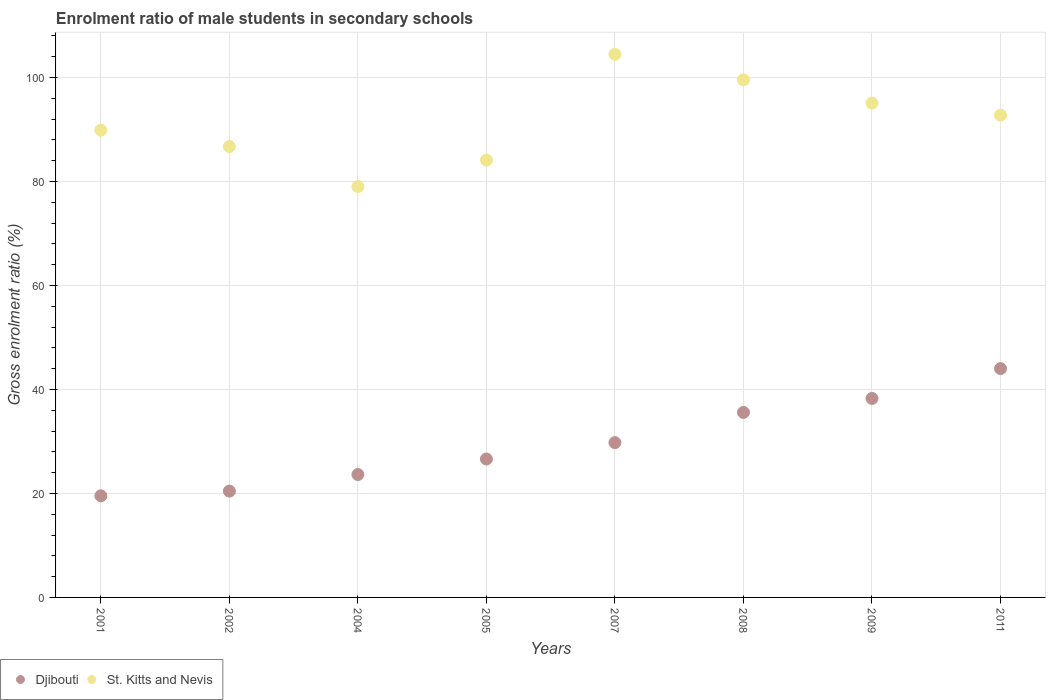How many different coloured dotlines are there?
Give a very brief answer. 2. What is the enrolment ratio of male students in secondary schools in St. Kitts and Nevis in 2007?
Make the answer very short. 104.44. Across all years, what is the maximum enrolment ratio of male students in secondary schools in Djibouti?
Offer a terse response. 44. Across all years, what is the minimum enrolment ratio of male students in secondary schools in St. Kitts and Nevis?
Your answer should be compact. 79.01. In which year was the enrolment ratio of male students in secondary schools in Djibouti maximum?
Give a very brief answer. 2011. In which year was the enrolment ratio of male students in secondary schools in St. Kitts and Nevis minimum?
Provide a succinct answer. 2004. What is the total enrolment ratio of male students in secondary schools in Djibouti in the graph?
Provide a short and direct response. 237.86. What is the difference between the enrolment ratio of male students in secondary schools in St. Kitts and Nevis in 2007 and that in 2008?
Ensure brevity in your answer.  4.9. What is the difference between the enrolment ratio of male students in secondary schools in Djibouti in 2004 and the enrolment ratio of male students in secondary schools in St. Kitts and Nevis in 2002?
Make the answer very short. -63.08. What is the average enrolment ratio of male students in secondary schools in St. Kitts and Nevis per year?
Give a very brief answer. 91.43. In the year 2007, what is the difference between the enrolment ratio of male students in secondary schools in Djibouti and enrolment ratio of male students in secondary schools in St. Kitts and Nevis?
Your response must be concise. -74.68. What is the ratio of the enrolment ratio of male students in secondary schools in St. Kitts and Nevis in 2001 to that in 2004?
Offer a very short reply. 1.14. Is the difference between the enrolment ratio of male students in secondary schools in Djibouti in 2002 and 2009 greater than the difference between the enrolment ratio of male students in secondary schools in St. Kitts and Nevis in 2002 and 2009?
Your response must be concise. No. What is the difference between the highest and the second highest enrolment ratio of male students in secondary schools in Djibouti?
Ensure brevity in your answer.  5.74. What is the difference between the highest and the lowest enrolment ratio of male students in secondary schools in Djibouti?
Give a very brief answer. 24.46. In how many years, is the enrolment ratio of male students in secondary schools in St. Kitts and Nevis greater than the average enrolment ratio of male students in secondary schools in St. Kitts and Nevis taken over all years?
Give a very brief answer. 4. Does the enrolment ratio of male students in secondary schools in St. Kitts and Nevis monotonically increase over the years?
Make the answer very short. No. Does the graph contain any zero values?
Provide a succinct answer. No. How many legend labels are there?
Ensure brevity in your answer.  2. What is the title of the graph?
Keep it short and to the point. Enrolment ratio of male students in secondary schools. Does "Turkmenistan" appear as one of the legend labels in the graph?
Give a very brief answer. No. What is the label or title of the X-axis?
Offer a very short reply. Years. What is the Gross enrolment ratio (%) of Djibouti in 2001?
Provide a short and direct response. 19.54. What is the Gross enrolment ratio (%) of St. Kitts and Nevis in 2001?
Provide a short and direct response. 89.86. What is the Gross enrolment ratio (%) in Djibouti in 2002?
Your answer should be compact. 20.45. What is the Gross enrolment ratio (%) of St. Kitts and Nevis in 2002?
Your answer should be very brief. 86.71. What is the Gross enrolment ratio (%) in Djibouti in 2004?
Your answer should be compact. 23.63. What is the Gross enrolment ratio (%) in St. Kitts and Nevis in 2004?
Keep it short and to the point. 79.01. What is the Gross enrolment ratio (%) in Djibouti in 2005?
Make the answer very short. 26.62. What is the Gross enrolment ratio (%) of St. Kitts and Nevis in 2005?
Make the answer very short. 84.11. What is the Gross enrolment ratio (%) of Djibouti in 2007?
Your response must be concise. 29.77. What is the Gross enrolment ratio (%) of St. Kitts and Nevis in 2007?
Your answer should be compact. 104.44. What is the Gross enrolment ratio (%) of Djibouti in 2008?
Your response must be concise. 35.58. What is the Gross enrolment ratio (%) of St. Kitts and Nevis in 2008?
Offer a very short reply. 99.54. What is the Gross enrolment ratio (%) of Djibouti in 2009?
Your answer should be compact. 38.27. What is the Gross enrolment ratio (%) in St. Kitts and Nevis in 2009?
Make the answer very short. 95.06. What is the Gross enrolment ratio (%) of Djibouti in 2011?
Give a very brief answer. 44. What is the Gross enrolment ratio (%) of St. Kitts and Nevis in 2011?
Your response must be concise. 92.74. Across all years, what is the maximum Gross enrolment ratio (%) in Djibouti?
Your answer should be very brief. 44. Across all years, what is the maximum Gross enrolment ratio (%) of St. Kitts and Nevis?
Offer a terse response. 104.44. Across all years, what is the minimum Gross enrolment ratio (%) of Djibouti?
Offer a terse response. 19.54. Across all years, what is the minimum Gross enrolment ratio (%) in St. Kitts and Nevis?
Make the answer very short. 79.01. What is the total Gross enrolment ratio (%) of Djibouti in the graph?
Your answer should be very brief. 237.86. What is the total Gross enrolment ratio (%) of St. Kitts and Nevis in the graph?
Keep it short and to the point. 731.47. What is the difference between the Gross enrolment ratio (%) of Djibouti in 2001 and that in 2002?
Your answer should be compact. -0.9. What is the difference between the Gross enrolment ratio (%) of St. Kitts and Nevis in 2001 and that in 2002?
Provide a succinct answer. 3.15. What is the difference between the Gross enrolment ratio (%) of Djibouti in 2001 and that in 2004?
Give a very brief answer. -4.09. What is the difference between the Gross enrolment ratio (%) of St. Kitts and Nevis in 2001 and that in 2004?
Ensure brevity in your answer.  10.85. What is the difference between the Gross enrolment ratio (%) in Djibouti in 2001 and that in 2005?
Keep it short and to the point. -7.07. What is the difference between the Gross enrolment ratio (%) in St. Kitts and Nevis in 2001 and that in 2005?
Ensure brevity in your answer.  5.75. What is the difference between the Gross enrolment ratio (%) in Djibouti in 2001 and that in 2007?
Offer a terse response. -10.22. What is the difference between the Gross enrolment ratio (%) in St. Kitts and Nevis in 2001 and that in 2007?
Offer a terse response. -14.58. What is the difference between the Gross enrolment ratio (%) in Djibouti in 2001 and that in 2008?
Keep it short and to the point. -16.03. What is the difference between the Gross enrolment ratio (%) of St. Kitts and Nevis in 2001 and that in 2008?
Keep it short and to the point. -9.68. What is the difference between the Gross enrolment ratio (%) of Djibouti in 2001 and that in 2009?
Your response must be concise. -18.72. What is the difference between the Gross enrolment ratio (%) in St. Kitts and Nevis in 2001 and that in 2009?
Offer a very short reply. -5.2. What is the difference between the Gross enrolment ratio (%) in Djibouti in 2001 and that in 2011?
Your answer should be very brief. -24.46. What is the difference between the Gross enrolment ratio (%) in St. Kitts and Nevis in 2001 and that in 2011?
Provide a short and direct response. -2.88. What is the difference between the Gross enrolment ratio (%) of Djibouti in 2002 and that in 2004?
Provide a succinct answer. -3.18. What is the difference between the Gross enrolment ratio (%) of St. Kitts and Nevis in 2002 and that in 2004?
Give a very brief answer. 7.69. What is the difference between the Gross enrolment ratio (%) in Djibouti in 2002 and that in 2005?
Keep it short and to the point. -6.17. What is the difference between the Gross enrolment ratio (%) in St. Kitts and Nevis in 2002 and that in 2005?
Ensure brevity in your answer.  2.6. What is the difference between the Gross enrolment ratio (%) of Djibouti in 2002 and that in 2007?
Your answer should be very brief. -9.32. What is the difference between the Gross enrolment ratio (%) of St. Kitts and Nevis in 2002 and that in 2007?
Keep it short and to the point. -17.74. What is the difference between the Gross enrolment ratio (%) of Djibouti in 2002 and that in 2008?
Give a very brief answer. -15.13. What is the difference between the Gross enrolment ratio (%) in St. Kitts and Nevis in 2002 and that in 2008?
Your answer should be compact. -12.83. What is the difference between the Gross enrolment ratio (%) in Djibouti in 2002 and that in 2009?
Give a very brief answer. -17.82. What is the difference between the Gross enrolment ratio (%) of St. Kitts and Nevis in 2002 and that in 2009?
Offer a terse response. -8.35. What is the difference between the Gross enrolment ratio (%) in Djibouti in 2002 and that in 2011?
Ensure brevity in your answer.  -23.56. What is the difference between the Gross enrolment ratio (%) in St. Kitts and Nevis in 2002 and that in 2011?
Give a very brief answer. -6.03. What is the difference between the Gross enrolment ratio (%) in Djibouti in 2004 and that in 2005?
Your answer should be very brief. -2.99. What is the difference between the Gross enrolment ratio (%) of St. Kitts and Nevis in 2004 and that in 2005?
Offer a terse response. -5.09. What is the difference between the Gross enrolment ratio (%) of Djibouti in 2004 and that in 2007?
Your response must be concise. -6.14. What is the difference between the Gross enrolment ratio (%) of St. Kitts and Nevis in 2004 and that in 2007?
Offer a terse response. -25.43. What is the difference between the Gross enrolment ratio (%) in Djibouti in 2004 and that in 2008?
Give a very brief answer. -11.95. What is the difference between the Gross enrolment ratio (%) of St. Kitts and Nevis in 2004 and that in 2008?
Provide a short and direct response. -20.53. What is the difference between the Gross enrolment ratio (%) in Djibouti in 2004 and that in 2009?
Ensure brevity in your answer.  -14.64. What is the difference between the Gross enrolment ratio (%) in St. Kitts and Nevis in 2004 and that in 2009?
Your answer should be compact. -16.05. What is the difference between the Gross enrolment ratio (%) in Djibouti in 2004 and that in 2011?
Your response must be concise. -20.37. What is the difference between the Gross enrolment ratio (%) of St. Kitts and Nevis in 2004 and that in 2011?
Your answer should be very brief. -13.72. What is the difference between the Gross enrolment ratio (%) of Djibouti in 2005 and that in 2007?
Offer a very short reply. -3.15. What is the difference between the Gross enrolment ratio (%) in St. Kitts and Nevis in 2005 and that in 2007?
Give a very brief answer. -20.34. What is the difference between the Gross enrolment ratio (%) in Djibouti in 2005 and that in 2008?
Provide a succinct answer. -8.96. What is the difference between the Gross enrolment ratio (%) in St. Kitts and Nevis in 2005 and that in 2008?
Your response must be concise. -15.43. What is the difference between the Gross enrolment ratio (%) of Djibouti in 2005 and that in 2009?
Offer a very short reply. -11.65. What is the difference between the Gross enrolment ratio (%) of St. Kitts and Nevis in 2005 and that in 2009?
Your answer should be compact. -10.96. What is the difference between the Gross enrolment ratio (%) in Djibouti in 2005 and that in 2011?
Give a very brief answer. -17.39. What is the difference between the Gross enrolment ratio (%) in St. Kitts and Nevis in 2005 and that in 2011?
Make the answer very short. -8.63. What is the difference between the Gross enrolment ratio (%) in Djibouti in 2007 and that in 2008?
Your response must be concise. -5.81. What is the difference between the Gross enrolment ratio (%) of St. Kitts and Nevis in 2007 and that in 2008?
Your answer should be compact. 4.9. What is the difference between the Gross enrolment ratio (%) of Djibouti in 2007 and that in 2009?
Give a very brief answer. -8.5. What is the difference between the Gross enrolment ratio (%) in St. Kitts and Nevis in 2007 and that in 2009?
Offer a very short reply. 9.38. What is the difference between the Gross enrolment ratio (%) of Djibouti in 2007 and that in 2011?
Keep it short and to the point. -14.24. What is the difference between the Gross enrolment ratio (%) of St. Kitts and Nevis in 2007 and that in 2011?
Your answer should be very brief. 11.71. What is the difference between the Gross enrolment ratio (%) of Djibouti in 2008 and that in 2009?
Your answer should be very brief. -2.69. What is the difference between the Gross enrolment ratio (%) of St. Kitts and Nevis in 2008 and that in 2009?
Your answer should be compact. 4.48. What is the difference between the Gross enrolment ratio (%) in Djibouti in 2008 and that in 2011?
Provide a succinct answer. -8.43. What is the difference between the Gross enrolment ratio (%) in St. Kitts and Nevis in 2008 and that in 2011?
Offer a very short reply. 6.8. What is the difference between the Gross enrolment ratio (%) of Djibouti in 2009 and that in 2011?
Give a very brief answer. -5.74. What is the difference between the Gross enrolment ratio (%) in St. Kitts and Nevis in 2009 and that in 2011?
Provide a short and direct response. 2.33. What is the difference between the Gross enrolment ratio (%) of Djibouti in 2001 and the Gross enrolment ratio (%) of St. Kitts and Nevis in 2002?
Your response must be concise. -67.16. What is the difference between the Gross enrolment ratio (%) in Djibouti in 2001 and the Gross enrolment ratio (%) in St. Kitts and Nevis in 2004?
Your response must be concise. -59.47. What is the difference between the Gross enrolment ratio (%) in Djibouti in 2001 and the Gross enrolment ratio (%) in St. Kitts and Nevis in 2005?
Keep it short and to the point. -64.56. What is the difference between the Gross enrolment ratio (%) of Djibouti in 2001 and the Gross enrolment ratio (%) of St. Kitts and Nevis in 2007?
Give a very brief answer. -84.9. What is the difference between the Gross enrolment ratio (%) of Djibouti in 2001 and the Gross enrolment ratio (%) of St. Kitts and Nevis in 2008?
Your answer should be very brief. -80. What is the difference between the Gross enrolment ratio (%) of Djibouti in 2001 and the Gross enrolment ratio (%) of St. Kitts and Nevis in 2009?
Make the answer very short. -75.52. What is the difference between the Gross enrolment ratio (%) of Djibouti in 2001 and the Gross enrolment ratio (%) of St. Kitts and Nevis in 2011?
Your answer should be very brief. -73.19. What is the difference between the Gross enrolment ratio (%) of Djibouti in 2002 and the Gross enrolment ratio (%) of St. Kitts and Nevis in 2004?
Keep it short and to the point. -58.57. What is the difference between the Gross enrolment ratio (%) in Djibouti in 2002 and the Gross enrolment ratio (%) in St. Kitts and Nevis in 2005?
Ensure brevity in your answer.  -63.66. What is the difference between the Gross enrolment ratio (%) in Djibouti in 2002 and the Gross enrolment ratio (%) in St. Kitts and Nevis in 2007?
Your answer should be compact. -84. What is the difference between the Gross enrolment ratio (%) of Djibouti in 2002 and the Gross enrolment ratio (%) of St. Kitts and Nevis in 2008?
Your answer should be very brief. -79.09. What is the difference between the Gross enrolment ratio (%) in Djibouti in 2002 and the Gross enrolment ratio (%) in St. Kitts and Nevis in 2009?
Make the answer very short. -74.61. What is the difference between the Gross enrolment ratio (%) in Djibouti in 2002 and the Gross enrolment ratio (%) in St. Kitts and Nevis in 2011?
Provide a short and direct response. -72.29. What is the difference between the Gross enrolment ratio (%) of Djibouti in 2004 and the Gross enrolment ratio (%) of St. Kitts and Nevis in 2005?
Offer a very short reply. -60.47. What is the difference between the Gross enrolment ratio (%) in Djibouti in 2004 and the Gross enrolment ratio (%) in St. Kitts and Nevis in 2007?
Your response must be concise. -80.81. What is the difference between the Gross enrolment ratio (%) in Djibouti in 2004 and the Gross enrolment ratio (%) in St. Kitts and Nevis in 2008?
Make the answer very short. -75.91. What is the difference between the Gross enrolment ratio (%) of Djibouti in 2004 and the Gross enrolment ratio (%) of St. Kitts and Nevis in 2009?
Provide a succinct answer. -71.43. What is the difference between the Gross enrolment ratio (%) in Djibouti in 2004 and the Gross enrolment ratio (%) in St. Kitts and Nevis in 2011?
Provide a succinct answer. -69.1. What is the difference between the Gross enrolment ratio (%) of Djibouti in 2005 and the Gross enrolment ratio (%) of St. Kitts and Nevis in 2007?
Offer a very short reply. -77.83. What is the difference between the Gross enrolment ratio (%) of Djibouti in 2005 and the Gross enrolment ratio (%) of St. Kitts and Nevis in 2008?
Ensure brevity in your answer.  -72.92. What is the difference between the Gross enrolment ratio (%) in Djibouti in 2005 and the Gross enrolment ratio (%) in St. Kitts and Nevis in 2009?
Your response must be concise. -68.44. What is the difference between the Gross enrolment ratio (%) of Djibouti in 2005 and the Gross enrolment ratio (%) of St. Kitts and Nevis in 2011?
Your response must be concise. -66.12. What is the difference between the Gross enrolment ratio (%) of Djibouti in 2007 and the Gross enrolment ratio (%) of St. Kitts and Nevis in 2008?
Make the answer very short. -69.77. What is the difference between the Gross enrolment ratio (%) in Djibouti in 2007 and the Gross enrolment ratio (%) in St. Kitts and Nevis in 2009?
Offer a terse response. -65.29. What is the difference between the Gross enrolment ratio (%) of Djibouti in 2007 and the Gross enrolment ratio (%) of St. Kitts and Nevis in 2011?
Keep it short and to the point. -62.97. What is the difference between the Gross enrolment ratio (%) of Djibouti in 2008 and the Gross enrolment ratio (%) of St. Kitts and Nevis in 2009?
Keep it short and to the point. -59.48. What is the difference between the Gross enrolment ratio (%) of Djibouti in 2008 and the Gross enrolment ratio (%) of St. Kitts and Nevis in 2011?
Your answer should be very brief. -57.16. What is the difference between the Gross enrolment ratio (%) of Djibouti in 2009 and the Gross enrolment ratio (%) of St. Kitts and Nevis in 2011?
Offer a very short reply. -54.47. What is the average Gross enrolment ratio (%) in Djibouti per year?
Provide a short and direct response. 29.73. What is the average Gross enrolment ratio (%) of St. Kitts and Nevis per year?
Give a very brief answer. 91.43. In the year 2001, what is the difference between the Gross enrolment ratio (%) of Djibouti and Gross enrolment ratio (%) of St. Kitts and Nevis?
Provide a short and direct response. -70.32. In the year 2002, what is the difference between the Gross enrolment ratio (%) of Djibouti and Gross enrolment ratio (%) of St. Kitts and Nevis?
Your answer should be compact. -66.26. In the year 2004, what is the difference between the Gross enrolment ratio (%) of Djibouti and Gross enrolment ratio (%) of St. Kitts and Nevis?
Provide a short and direct response. -55.38. In the year 2005, what is the difference between the Gross enrolment ratio (%) in Djibouti and Gross enrolment ratio (%) in St. Kitts and Nevis?
Your response must be concise. -57.49. In the year 2007, what is the difference between the Gross enrolment ratio (%) in Djibouti and Gross enrolment ratio (%) in St. Kitts and Nevis?
Offer a terse response. -74.68. In the year 2008, what is the difference between the Gross enrolment ratio (%) of Djibouti and Gross enrolment ratio (%) of St. Kitts and Nevis?
Your answer should be compact. -63.96. In the year 2009, what is the difference between the Gross enrolment ratio (%) of Djibouti and Gross enrolment ratio (%) of St. Kitts and Nevis?
Ensure brevity in your answer.  -56.79. In the year 2011, what is the difference between the Gross enrolment ratio (%) of Djibouti and Gross enrolment ratio (%) of St. Kitts and Nevis?
Ensure brevity in your answer.  -48.73. What is the ratio of the Gross enrolment ratio (%) of Djibouti in 2001 to that in 2002?
Offer a terse response. 0.96. What is the ratio of the Gross enrolment ratio (%) of St. Kitts and Nevis in 2001 to that in 2002?
Your answer should be compact. 1.04. What is the ratio of the Gross enrolment ratio (%) of Djibouti in 2001 to that in 2004?
Provide a succinct answer. 0.83. What is the ratio of the Gross enrolment ratio (%) of St. Kitts and Nevis in 2001 to that in 2004?
Provide a short and direct response. 1.14. What is the ratio of the Gross enrolment ratio (%) of Djibouti in 2001 to that in 2005?
Keep it short and to the point. 0.73. What is the ratio of the Gross enrolment ratio (%) of St. Kitts and Nevis in 2001 to that in 2005?
Offer a very short reply. 1.07. What is the ratio of the Gross enrolment ratio (%) in Djibouti in 2001 to that in 2007?
Your answer should be compact. 0.66. What is the ratio of the Gross enrolment ratio (%) of St. Kitts and Nevis in 2001 to that in 2007?
Offer a very short reply. 0.86. What is the ratio of the Gross enrolment ratio (%) in Djibouti in 2001 to that in 2008?
Keep it short and to the point. 0.55. What is the ratio of the Gross enrolment ratio (%) of St. Kitts and Nevis in 2001 to that in 2008?
Offer a terse response. 0.9. What is the ratio of the Gross enrolment ratio (%) in Djibouti in 2001 to that in 2009?
Your response must be concise. 0.51. What is the ratio of the Gross enrolment ratio (%) in St. Kitts and Nevis in 2001 to that in 2009?
Make the answer very short. 0.95. What is the ratio of the Gross enrolment ratio (%) in Djibouti in 2001 to that in 2011?
Your answer should be compact. 0.44. What is the ratio of the Gross enrolment ratio (%) in Djibouti in 2002 to that in 2004?
Your response must be concise. 0.87. What is the ratio of the Gross enrolment ratio (%) in St. Kitts and Nevis in 2002 to that in 2004?
Keep it short and to the point. 1.1. What is the ratio of the Gross enrolment ratio (%) in Djibouti in 2002 to that in 2005?
Provide a short and direct response. 0.77. What is the ratio of the Gross enrolment ratio (%) in St. Kitts and Nevis in 2002 to that in 2005?
Make the answer very short. 1.03. What is the ratio of the Gross enrolment ratio (%) of Djibouti in 2002 to that in 2007?
Your answer should be very brief. 0.69. What is the ratio of the Gross enrolment ratio (%) in St. Kitts and Nevis in 2002 to that in 2007?
Your answer should be compact. 0.83. What is the ratio of the Gross enrolment ratio (%) of Djibouti in 2002 to that in 2008?
Your answer should be compact. 0.57. What is the ratio of the Gross enrolment ratio (%) in St. Kitts and Nevis in 2002 to that in 2008?
Your answer should be very brief. 0.87. What is the ratio of the Gross enrolment ratio (%) in Djibouti in 2002 to that in 2009?
Offer a very short reply. 0.53. What is the ratio of the Gross enrolment ratio (%) in St. Kitts and Nevis in 2002 to that in 2009?
Ensure brevity in your answer.  0.91. What is the ratio of the Gross enrolment ratio (%) in Djibouti in 2002 to that in 2011?
Make the answer very short. 0.46. What is the ratio of the Gross enrolment ratio (%) of St. Kitts and Nevis in 2002 to that in 2011?
Keep it short and to the point. 0.94. What is the ratio of the Gross enrolment ratio (%) of Djibouti in 2004 to that in 2005?
Offer a very short reply. 0.89. What is the ratio of the Gross enrolment ratio (%) of St. Kitts and Nevis in 2004 to that in 2005?
Give a very brief answer. 0.94. What is the ratio of the Gross enrolment ratio (%) in Djibouti in 2004 to that in 2007?
Give a very brief answer. 0.79. What is the ratio of the Gross enrolment ratio (%) in St. Kitts and Nevis in 2004 to that in 2007?
Offer a very short reply. 0.76. What is the ratio of the Gross enrolment ratio (%) of Djibouti in 2004 to that in 2008?
Make the answer very short. 0.66. What is the ratio of the Gross enrolment ratio (%) in St. Kitts and Nevis in 2004 to that in 2008?
Keep it short and to the point. 0.79. What is the ratio of the Gross enrolment ratio (%) in Djibouti in 2004 to that in 2009?
Provide a succinct answer. 0.62. What is the ratio of the Gross enrolment ratio (%) in St. Kitts and Nevis in 2004 to that in 2009?
Ensure brevity in your answer.  0.83. What is the ratio of the Gross enrolment ratio (%) of Djibouti in 2004 to that in 2011?
Provide a short and direct response. 0.54. What is the ratio of the Gross enrolment ratio (%) in St. Kitts and Nevis in 2004 to that in 2011?
Offer a very short reply. 0.85. What is the ratio of the Gross enrolment ratio (%) of Djibouti in 2005 to that in 2007?
Ensure brevity in your answer.  0.89. What is the ratio of the Gross enrolment ratio (%) of St. Kitts and Nevis in 2005 to that in 2007?
Keep it short and to the point. 0.81. What is the ratio of the Gross enrolment ratio (%) in Djibouti in 2005 to that in 2008?
Give a very brief answer. 0.75. What is the ratio of the Gross enrolment ratio (%) of St. Kitts and Nevis in 2005 to that in 2008?
Provide a succinct answer. 0.84. What is the ratio of the Gross enrolment ratio (%) in Djibouti in 2005 to that in 2009?
Your answer should be compact. 0.7. What is the ratio of the Gross enrolment ratio (%) of St. Kitts and Nevis in 2005 to that in 2009?
Make the answer very short. 0.88. What is the ratio of the Gross enrolment ratio (%) in Djibouti in 2005 to that in 2011?
Your answer should be compact. 0.6. What is the ratio of the Gross enrolment ratio (%) in St. Kitts and Nevis in 2005 to that in 2011?
Your answer should be very brief. 0.91. What is the ratio of the Gross enrolment ratio (%) of Djibouti in 2007 to that in 2008?
Your response must be concise. 0.84. What is the ratio of the Gross enrolment ratio (%) of St. Kitts and Nevis in 2007 to that in 2008?
Provide a short and direct response. 1.05. What is the ratio of the Gross enrolment ratio (%) in Djibouti in 2007 to that in 2009?
Provide a short and direct response. 0.78. What is the ratio of the Gross enrolment ratio (%) of St. Kitts and Nevis in 2007 to that in 2009?
Your response must be concise. 1.1. What is the ratio of the Gross enrolment ratio (%) in Djibouti in 2007 to that in 2011?
Provide a succinct answer. 0.68. What is the ratio of the Gross enrolment ratio (%) of St. Kitts and Nevis in 2007 to that in 2011?
Provide a succinct answer. 1.13. What is the ratio of the Gross enrolment ratio (%) of Djibouti in 2008 to that in 2009?
Offer a terse response. 0.93. What is the ratio of the Gross enrolment ratio (%) of St. Kitts and Nevis in 2008 to that in 2009?
Your answer should be compact. 1.05. What is the ratio of the Gross enrolment ratio (%) of Djibouti in 2008 to that in 2011?
Your answer should be very brief. 0.81. What is the ratio of the Gross enrolment ratio (%) of St. Kitts and Nevis in 2008 to that in 2011?
Your answer should be very brief. 1.07. What is the ratio of the Gross enrolment ratio (%) in Djibouti in 2009 to that in 2011?
Make the answer very short. 0.87. What is the ratio of the Gross enrolment ratio (%) of St. Kitts and Nevis in 2009 to that in 2011?
Your response must be concise. 1.03. What is the difference between the highest and the second highest Gross enrolment ratio (%) in Djibouti?
Ensure brevity in your answer.  5.74. What is the difference between the highest and the second highest Gross enrolment ratio (%) in St. Kitts and Nevis?
Give a very brief answer. 4.9. What is the difference between the highest and the lowest Gross enrolment ratio (%) of Djibouti?
Make the answer very short. 24.46. What is the difference between the highest and the lowest Gross enrolment ratio (%) of St. Kitts and Nevis?
Offer a very short reply. 25.43. 